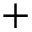Convert formula to latex. <formula><loc_0><loc_0><loc_500><loc_500>+</formula> 